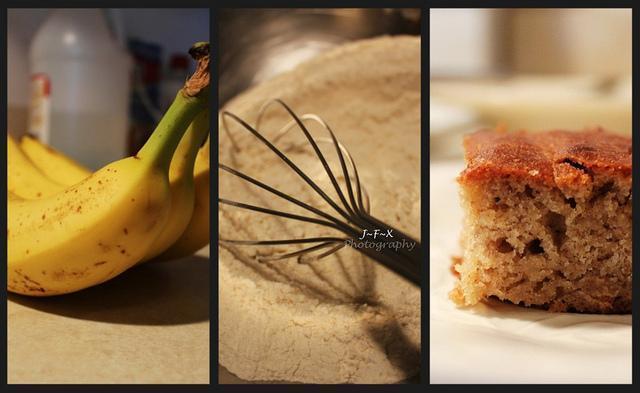How many wires does the whisk have?
Give a very brief answer. 10. How many people are wearing sandals?
Give a very brief answer. 0. 